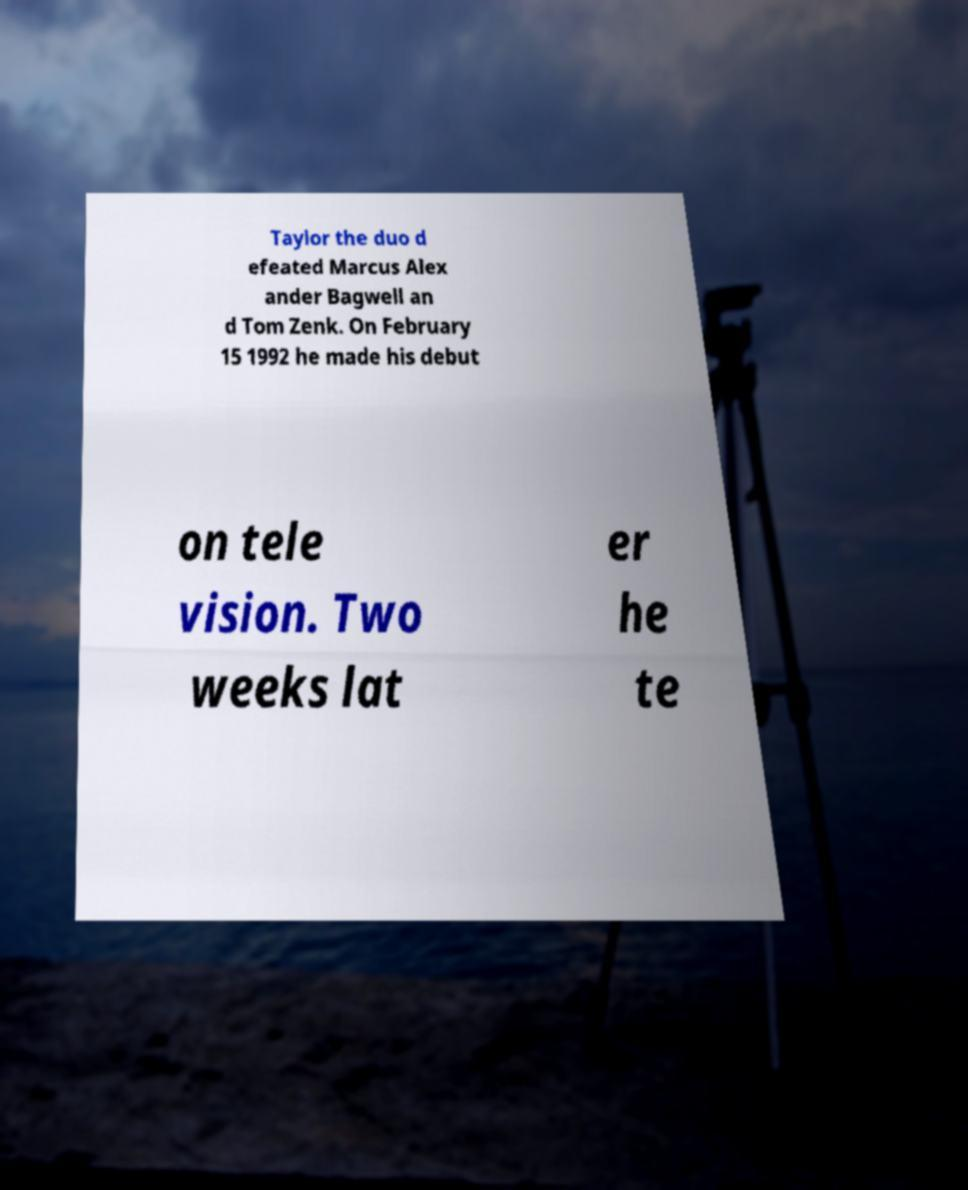Please read and relay the text visible in this image. What does it say? Taylor the duo d efeated Marcus Alex ander Bagwell an d Tom Zenk. On February 15 1992 he made his debut on tele vision. Two weeks lat er he te 